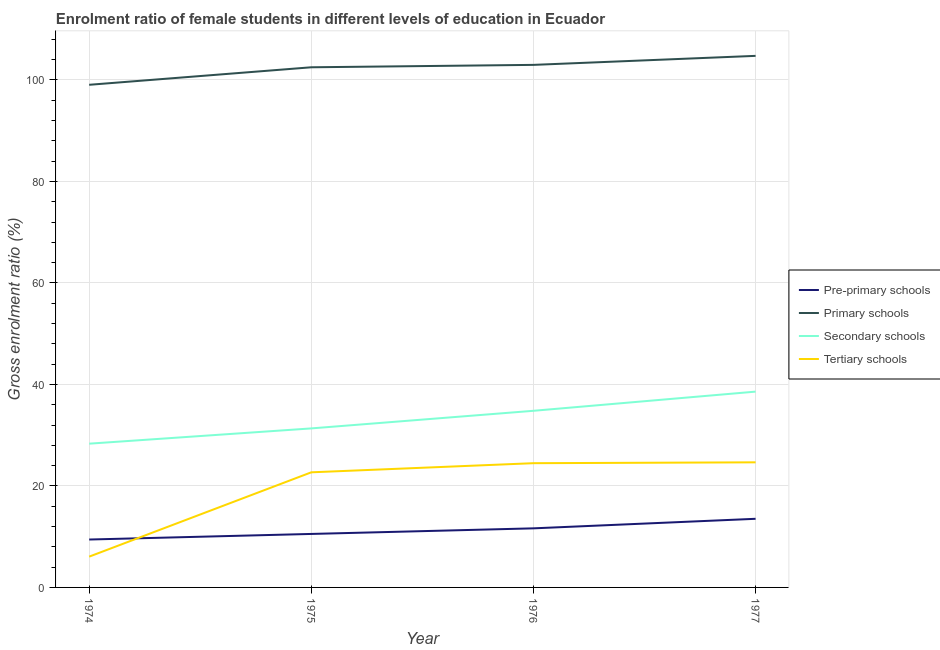Is the number of lines equal to the number of legend labels?
Provide a succinct answer. Yes. What is the gross enrolment ratio(male) in tertiary schools in 1976?
Give a very brief answer. 24.48. Across all years, what is the maximum gross enrolment ratio(male) in tertiary schools?
Your answer should be compact. 24.65. Across all years, what is the minimum gross enrolment ratio(male) in pre-primary schools?
Offer a terse response. 9.44. In which year was the gross enrolment ratio(male) in pre-primary schools minimum?
Keep it short and to the point. 1974. What is the total gross enrolment ratio(male) in primary schools in the graph?
Make the answer very short. 409.22. What is the difference between the gross enrolment ratio(male) in pre-primary schools in 1974 and that in 1976?
Offer a very short reply. -2.2. What is the difference between the gross enrolment ratio(male) in primary schools in 1977 and the gross enrolment ratio(male) in tertiary schools in 1976?
Your response must be concise. 80.26. What is the average gross enrolment ratio(male) in pre-primary schools per year?
Ensure brevity in your answer.  11.29. In the year 1975, what is the difference between the gross enrolment ratio(male) in primary schools and gross enrolment ratio(male) in tertiary schools?
Ensure brevity in your answer.  79.8. What is the ratio of the gross enrolment ratio(male) in pre-primary schools in 1975 to that in 1977?
Keep it short and to the point. 0.78. Is the gross enrolment ratio(male) in tertiary schools in 1974 less than that in 1975?
Your answer should be compact. Yes. Is the difference between the gross enrolment ratio(male) in pre-primary schools in 1974 and 1977 greater than the difference between the gross enrolment ratio(male) in secondary schools in 1974 and 1977?
Provide a succinct answer. Yes. What is the difference between the highest and the second highest gross enrolment ratio(male) in secondary schools?
Provide a succinct answer. 3.78. What is the difference between the highest and the lowest gross enrolment ratio(male) in pre-primary schools?
Your answer should be very brief. 4.08. Is the sum of the gross enrolment ratio(male) in tertiary schools in 1975 and 1976 greater than the maximum gross enrolment ratio(male) in pre-primary schools across all years?
Provide a short and direct response. Yes. Is it the case that in every year, the sum of the gross enrolment ratio(male) in pre-primary schools and gross enrolment ratio(male) in primary schools is greater than the sum of gross enrolment ratio(male) in tertiary schools and gross enrolment ratio(male) in secondary schools?
Keep it short and to the point. Yes. Is the gross enrolment ratio(male) in tertiary schools strictly less than the gross enrolment ratio(male) in primary schools over the years?
Your answer should be compact. Yes. How many lines are there?
Ensure brevity in your answer.  4. How many years are there in the graph?
Give a very brief answer. 4. Are the values on the major ticks of Y-axis written in scientific E-notation?
Offer a very short reply. No. How many legend labels are there?
Provide a short and direct response. 4. How are the legend labels stacked?
Provide a succinct answer. Vertical. What is the title of the graph?
Your answer should be compact. Enrolment ratio of female students in different levels of education in Ecuador. Does "Secondary vocational" appear as one of the legend labels in the graph?
Provide a short and direct response. No. What is the label or title of the X-axis?
Give a very brief answer. Year. What is the label or title of the Y-axis?
Your response must be concise. Gross enrolment ratio (%). What is the Gross enrolment ratio (%) of Pre-primary schools in 1974?
Your answer should be compact. 9.44. What is the Gross enrolment ratio (%) of Primary schools in 1974?
Your response must be concise. 99.04. What is the Gross enrolment ratio (%) of Secondary schools in 1974?
Offer a terse response. 28.33. What is the Gross enrolment ratio (%) of Tertiary schools in 1974?
Provide a short and direct response. 6.07. What is the Gross enrolment ratio (%) of Pre-primary schools in 1975?
Keep it short and to the point. 10.54. What is the Gross enrolment ratio (%) of Primary schools in 1975?
Offer a very short reply. 102.49. What is the Gross enrolment ratio (%) of Secondary schools in 1975?
Your answer should be very brief. 31.33. What is the Gross enrolment ratio (%) in Tertiary schools in 1975?
Provide a short and direct response. 22.68. What is the Gross enrolment ratio (%) of Pre-primary schools in 1976?
Provide a short and direct response. 11.64. What is the Gross enrolment ratio (%) of Primary schools in 1976?
Your answer should be very brief. 102.96. What is the Gross enrolment ratio (%) of Secondary schools in 1976?
Provide a short and direct response. 34.8. What is the Gross enrolment ratio (%) in Tertiary schools in 1976?
Provide a succinct answer. 24.48. What is the Gross enrolment ratio (%) in Pre-primary schools in 1977?
Offer a very short reply. 13.52. What is the Gross enrolment ratio (%) in Primary schools in 1977?
Make the answer very short. 104.74. What is the Gross enrolment ratio (%) in Secondary schools in 1977?
Keep it short and to the point. 38.58. What is the Gross enrolment ratio (%) of Tertiary schools in 1977?
Give a very brief answer. 24.65. Across all years, what is the maximum Gross enrolment ratio (%) in Pre-primary schools?
Ensure brevity in your answer.  13.52. Across all years, what is the maximum Gross enrolment ratio (%) of Primary schools?
Give a very brief answer. 104.74. Across all years, what is the maximum Gross enrolment ratio (%) in Secondary schools?
Offer a very short reply. 38.58. Across all years, what is the maximum Gross enrolment ratio (%) in Tertiary schools?
Your answer should be compact. 24.65. Across all years, what is the minimum Gross enrolment ratio (%) of Pre-primary schools?
Ensure brevity in your answer.  9.44. Across all years, what is the minimum Gross enrolment ratio (%) in Primary schools?
Your response must be concise. 99.04. Across all years, what is the minimum Gross enrolment ratio (%) in Secondary schools?
Offer a terse response. 28.33. Across all years, what is the minimum Gross enrolment ratio (%) of Tertiary schools?
Provide a succinct answer. 6.07. What is the total Gross enrolment ratio (%) of Pre-primary schools in the graph?
Offer a terse response. 45.14. What is the total Gross enrolment ratio (%) in Primary schools in the graph?
Your response must be concise. 409.22. What is the total Gross enrolment ratio (%) in Secondary schools in the graph?
Your response must be concise. 133.04. What is the total Gross enrolment ratio (%) of Tertiary schools in the graph?
Your answer should be very brief. 77.88. What is the difference between the Gross enrolment ratio (%) in Pre-primary schools in 1974 and that in 1975?
Your answer should be compact. -1.1. What is the difference between the Gross enrolment ratio (%) of Primary schools in 1974 and that in 1975?
Offer a very short reply. -3.45. What is the difference between the Gross enrolment ratio (%) of Secondary schools in 1974 and that in 1975?
Ensure brevity in your answer.  -3.01. What is the difference between the Gross enrolment ratio (%) in Tertiary schools in 1974 and that in 1975?
Give a very brief answer. -16.62. What is the difference between the Gross enrolment ratio (%) in Pre-primary schools in 1974 and that in 1976?
Give a very brief answer. -2.2. What is the difference between the Gross enrolment ratio (%) of Primary schools in 1974 and that in 1976?
Offer a very short reply. -3.92. What is the difference between the Gross enrolment ratio (%) of Secondary schools in 1974 and that in 1976?
Keep it short and to the point. -6.48. What is the difference between the Gross enrolment ratio (%) of Tertiary schools in 1974 and that in 1976?
Your answer should be compact. -18.41. What is the difference between the Gross enrolment ratio (%) of Pre-primary schools in 1974 and that in 1977?
Your response must be concise. -4.08. What is the difference between the Gross enrolment ratio (%) in Primary schools in 1974 and that in 1977?
Your answer should be very brief. -5.7. What is the difference between the Gross enrolment ratio (%) in Secondary schools in 1974 and that in 1977?
Your answer should be very brief. -10.25. What is the difference between the Gross enrolment ratio (%) in Tertiary schools in 1974 and that in 1977?
Provide a short and direct response. -18.58. What is the difference between the Gross enrolment ratio (%) of Primary schools in 1975 and that in 1976?
Your answer should be compact. -0.47. What is the difference between the Gross enrolment ratio (%) of Secondary schools in 1975 and that in 1976?
Your response must be concise. -3.47. What is the difference between the Gross enrolment ratio (%) in Tertiary schools in 1975 and that in 1976?
Provide a succinct answer. -1.8. What is the difference between the Gross enrolment ratio (%) of Pre-primary schools in 1975 and that in 1977?
Ensure brevity in your answer.  -2.98. What is the difference between the Gross enrolment ratio (%) in Primary schools in 1975 and that in 1977?
Give a very brief answer. -2.25. What is the difference between the Gross enrolment ratio (%) of Secondary schools in 1975 and that in 1977?
Provide a succinct answer. -7.25. What is the difference between the Gross enrolment ratio (%) of Tertiary schools in 1975 and that in 1977?
Provide a short and direct response. -1.97. What is the difference between the Gross enrolment ratio (%) in Pre-primary schools in 1976 and that in 1977?
Offer a terse response. -1.88. What is the difference between the Gross enrolment ratio (%) in Primary schools in 1976 and that in 1977?
Ensure brevity in your answer.  -1.78. What is the difference between the Gross enrolment ratio (%) in Secondary schools in 1976 and that in 1977?
Provide a succinct answer. -3.78. What is the difference between the Gross enrolment ratio (%) of Tertiary schools in 1976 and that in 1977?
Offer a terse response. -0.17. What is the difference between the Gross enrolment ratio (%) in Pre-primary schools in 1974 and the Gross enrolment ratio (%) in Primary schools in 1975?
Keep it short and to the point. -93.05. What is the difference between the Gross enrolment ratio (%) in Pre-primary schools in 1974 and the Gross enrolment ratio (%) in Secondary schools in 1975?
Your response must be concise. -21.89. What is the difference between the Gross enrolment ratio (%) in Pre-primary schools in 1974 and the Gross enrolment ratio (%) in Tertiary schools in 1975?
Offer a very short reply. -13.24. What is the difference between the Gross enrolment ratio (%) of Primary schools in 1974 and the Gross enrolment ratio (%) of Secondary schools in 1975?
Give a very brief answer. 67.7. What is the difference between the Gross enrolment ratio (%) of Primary schools in 1974 and the Gross enrolment ratio (%) of Tertiary schools in 1975?
Give a very brief answer. 76.35. What is the difference between the Gross enrolment ratio (%) in Secondary schools in 1974 and the Gross enrolment ratio (%) in Tertiary schools in 1975?
Provide a succinct answer. 5.64. What is the difference between the Gross enrolment ratio (%) of Pre-primary schools in 1974 and the Gross enrolment ratio (%) of Primary schools in 1976?
Your answer should be compact. -93.52. What is the difference between the Gross enrolment ratio (%) in Pre-primary schools in 1974 and the Gross enrolment ratio (%) in Secondary schools in 1976?
Ensure brevity in your answer.  -25.36. What is the difference between the Gross enrolment ratio (%) of Pre-primary schools in 1974 and the Gross enrolment ratio (%) of Tertiary schools in 1976?
Provide a succinct answer. -15.04. What is the difference between the Gross enrolment ratio (%) in Primary schools in 1974 and the Gross enrolment ratio (%) in Secondary schools in 1976?
Give a very brief answer. 64.23. What is the difference between the Gross enrolment ratio (%) of Primary schools in 1974 and the Gross enrolment ratio (%) of Tertiary schools in 1976?
Your response must be concise. 74.56. What is the difference between the Gross enrolment ratio (%) of Secondary schools in 1974 and the Gross enrolment ratio (%) of Tertiary schools in 1976?
Offer a terse response. 3.85. What is the difference between the Gross enrolment ratio (%) in Pre-primary schools in 1974 and the Gross enrolment ratio (%) in Primary schools in 1977?
Ensure brevity in your answer.  -95.3. What is the difference between the Gross enrolment ratio (%) of Pre-primary schools in 1974 and the Gross enrolment ratio (%) of Secondary schools in 1977?
Your response must be concise. -29.14. What is the difference between the Gross enrolment ratio (%) of Pre-primary schools in 1974 and the Gross enrolment ratio (%) of Tertiary schools in 1977?
Your response must be concise. -15.21. What is the difference between the Gross enrolment ratio (%) of Primary schools in 1974 and the Gross enrolment ratio (%) of Secondary schools in 1977?
Your answer should be compact. 60.46. What is the difference between the Gross enrolment ratio (%) of Primary schools in 1974 and the Gross enrolment ratio (%) of Tertiary schools in 1977?
Keep it short and to the point. 74.39. What is the difference between the Gross enrolment ratio (%) of Secondary schools in 1974 and the Gross enrolment ratio (%) of Tertiary schools in 1977?
Give a very brief answer. 3.68. What is the difference between the Gross enrolment ratio (%) in Pre-primary schools in 1975 and the Gross enrolment ratio (%) in Primary schools in 1976?
Provide a short and direct response. -92.42. What is the difference between the Gross enrolment ratio (%) in Pre-primary schools in 1975 and the Gross enrolment ratio (%) in Secondary schools in 1976?
Your answer should be very brief. -24.26. What is the difference between the Gross enrolment ratio (%) in Pre-primary schools in 1975 and the Gross enrolment ratio (%) in Tertiary schools in 1976?
Give a very brief answer. -13.94. What is the difference between the Gross enrolment ratio (%) in Primary schools in 1975 and the Gross enrolment ratio (%) in Secondary schools in 1976?
Your answer should be very brief. 67.68. What is the difference between the Gross enrolment ratio (%) in Primary schools in 1975 and the Gross enrolment ratio (%) in Tertiary schools in 1976?
Your answer should be compact. 78.01. What is the difference between the Gross enrolment ratio (%) in Secondary schools in 1975 and the Gross enrolment ratio (%) in Tertiary schools in 1976?
Your response must be concise. 6.85. What is the difference between the Gross enrolment ratio (%) in Pre-primary schools in 1975 and the Gross enrolment ratio (%) in Primary schools in 1977?
Your answer should be compact. -94.2. What is the difference between the Gross enrolment ratio (%) of Pre-primary schools in 1975 and the Gross enrolment ratio (%) of Secondary schools in 1977?
Ensure brevity in your answer.  -28.04. What is the difference between the Gross enrolment ratio (%) of Pre-primary schools in 1975 and the Gross enrolment ratio (%) of Tertiary schools in 1977?
Offer a very short reply. -14.11. What is the difference between the Gross enrolment ratio (%) of Primary schools in 1975 and the Gross enrolment ratio (%) of Secondary schools in 1977?
Make the answer very short. 63.91. What is the difference between the Gross enrolment ratio (%) of Primary schools in 1975 and the Gross enrolment ratio (%) of Tertiary schools in 1977?
Provide a succinct answer. 77.84. What is the difference between the Gross enrolment ratio (%) in Secondary schools in 1975 and the Gross enrolment ratio (%) in Tertiary schools in 1977?
Ensure brevity in your answer.  6.68. What is the difference between the Gross enrolment ratio (%) of Pre-primary schools in 1976 and the Gross enrolment ratio (%) of Primary schools in 1977?
Offer a terse response. -93.1. What is the difference between the Gross enrolment ratio (%) of Pre-primary schools in 1976 and the Gross enrolment ratio (%) of Secondary schools in 1977?
Give a very brief answer. -26.94. What is the difference between the Gross enrolment ratio (%) of Pre-primary schools in 1976 and the Gross enrolment ratio (%) of Tertiary schools in 1977?
Offer a very short reply. -13.01. What is the difference between the Gross enrolment ratio (%) of Primary schools in 1976 and the Gross enrolment ratio (%) of Secondary schools in 1977?
Offer a very short reply. 64.38. What is the difference between the Gross enrolment ratio (%) of Primary schools in 1976 and the Gross enrolment ratio (%) of Tertiary schools in 1977?
Your answer should be compact. 78.31. What is the difference between the Gross enrolment ratio (%) of Secondary schools in 1976 and the Gross enrolment ratio (%) of Tertiary schools in 1977?
Keep it short and to the point. 10.15. What is the average Gross enrolment ratio (%) of Pre-primary schools per year?
Give a very brief answer. 11.29. What is the average Gross enrolment ratio (%) of Primary schools per year?
Offer a very short reply. 102.3. What is the average Gross enrolment ratio (%) in Secondary schools per year?
Ensure brevity in your answer.  33.26. What is the average Gross enrolment ratio (%) in Tertiary schools per year?
Give a very brief answer. 19.47. In the year 1974, what is the difference between the Gross enrolment ratio (%) in Pre-primary schools and Gross enrolment ratio (%) in Primary schools?
Keep it short and to the point. -89.6. In the year 1974, what is the difference between the Gross enrolment ratio (%) in Pre-primary schools and Gross enrolment ratio (%) in Secondary schools?
Offer a very short reply. -18.89. In the year 1974, what is the difference between the Gross enrolment ratio (%) in Pre-primary schools and Gross enrolment ratio (%) in Tertiary schools?
Your response must be concise. 3.37. In the year 1974, what is the difference between the Gross enrolment ratio (%) in Primary schools and Gross enrolment ratio (%) in Secondary schools?
Provide a short and direct response. 70.71. In the year 1974, what is the difference between the Gross enrolment ratio (%) in Primary schools and Gross enrolment ratio (%) in Tertiary schools?
Provide a short and direct response. 92.97. In the year 1974, what is the difference between the Gross enrolment ratio (%) of Secondary schools and Gross enrolment ratio (%) of Tertiary schools?
Provide a short and direct response. 22.26. In the year 1975, what is the difference between the Gross enrolment ratio (%) of Pre-primary schools and Gross enrolment ratio (%) of Primary schools?
Make the answer very short. -91.95. In the year 1975, what is the difference between the Gross enrolment ratio (%) in Pre-primary schools and Gross enrolment ratio (%) in Secondary schools?
Keep it short and to the point. -20.79. In the year 1975, what is the difference between the Gross enrolment ratio (%) of Pre-primary schools and Gross enrolment ratio (%) of Tertiary schools?
Make the answer very short. -12.14. In the year 1975, what is the difference between the Gross enrolment ratio (%) in Primary schools and Gross enrolment ratio (%) in Secondary schools?
Offer a very short reply. 71.15. In the year 1975, what is the difference between the Gross enrolment ratio (%) in Primary schools and Gross enrolment ratio (%) in Tertiary schools?
Keep it short and to the point. 79.8. In the year 1975, what is the difference between the Gross enrolment ratio (%) in Secondary schools and Gross enrolment ratio (%) in Tertiary schools?
Provide a short and direct response. 8.65. In the year 1976, what is the difference between the Gross enrolment ratio (%) of Pre-primary schools and Gross enrolment ratio (%) of Primary schools?
Your answer should be very brief. -91.32. In the year 1976, what is the difference between the Gross enrolment ratio (%) of Pre-primary schools and Gross enrolment ratio (%) of Secondary schools?
Provide a succinct answer. -23.16. In the year 1976, what is the difference between the Gross enrolment ratio (%) in Pre-primary schools and Gross enrolment ratio (%) in Tertiary schools?
Offer a terse response. -12.84. In the year 1976, what is the difference between the Gross enrolment ratio (%) in Primary schools and Gross enrolment ratio (%) in Secondary schools?
Offer a very short reply. 68.16. In the year 1976, what is the difference between the Gross enrolment ratio (%) in Primary schools and Gross enrolment ratio (%) in Tertiary schools?
Make the answer very short. 78.48. In the year 1976, what is the difference between the Gross enrolment ratio (%) of Secondary schools and Gross enrolment ratio (%) of Tertiary schools?
Ensure brevity in your answer.  10.32. In the year 1977, what is the difference between the Gross enrolment ratio (%) of Pre-primary schools and Gross enrolment ratio (%) of Primary schools?
Provide a succinct answer. -91.21. In the year 1977, what is the difference between the Gross enrolment ratio (%) of Pre-primary schools and Gross enrolment ratio (%) of Secondary schools?
Provide a short and direct response. -25.06. In the year 1977, what is the difference between the Gross enrolment ratio (%) of Pre-primary schools and Gross enrolment ratio (%) of Tertiary schools?
Make the answer very short. -11.13. In the year 1977, what is the difference between the Gross enrolment ratio (%) of Primary schools and Gross enrolment ratio (%) of Secondary schools?
Offer a very short reply. 66.16. In the year 1977, what is the difference between the Gross enrolment ratio (%) in Primary schools and Gross enrolment ratio (%) in Tertiary schools?
Make the answer very short. 80.09. In the year 1977, what is the difference between the Gross enrolment ratio (%) in Secondary schools and Gross enrolment ratio (%) in Tertiary schools?
Provide a short and direct response. 13.93. What is the ratio of the Gross enrolment ratio (%) of Pre-primary schools in 1974 to that in 1975?
Offer a very short reply. 0.9. What is the ratio of the Gross enrolment ratio (%) of Primary schools in 1974 to that in 1975?
Provide a short and direct response. 0.97. What is the ratio of the Gross enrolment ratio (%) of Secondary schools in 1974 to that in 1975?
Offer a terse response. 0.9. What is the ratio of the Gross enrolment ratio (%) in Tertiary schools in 1974 to that in 1975?
Your answer should be compact. 0.27. What is the ratio of the Gross enrolment ratio (%) of Pre-primary schools in 1974 to that in 1976?
Offer a very short reply. 0.81. What is the ratio of the Gross enrolment ratio (%) of Primary schools in 1974 to that in 1976?
Your answer should be very brief. 0.96. What is the ratio of the Gross enrolment ratio (%) of Secondary schools in 1974 to that in 1976?
Provide a short and direct response. 0.81. What is the ratio of the Gross enrolment ratio (%) in Tertiary schools in 1974 to that in 1976?
Give a very brief answer. 0.25. What is the ratio of the Gross enrolment ratio (%) of Pre-primary schools in 1974 to that in 1977?
Keep it short and to the point. 0.7. What is the ratio of the Gross enrolment ratio (%) in Primary schools in 1974 to that in 1977?
Offer a terse response. 0.95. What is the ratio of the Gross enrolment ratio (%) of Secondary schools in 1974 to that in 1977?
Keep it short and to the point. 0.73. What is the ratio of the Gross enrolment ratio (%) of Tertiary schools in 1974 to that in 1977?
Your response must be concise. 0.25. What is the ratio of the Gross enrolment ratio (%) of Pre-primary schools in 1975 to that in 1976?
Your response must be concise. 0.91. What is the ratio of the Gross enrolment ratio (%) in Primary schools in 1975 to that in 1976?
Provide a succinct answer. 1. What is the ratio of the Gross enrolment ratio (%) of Secondary schools in 1975 to that in 1976?
Ensure brevity in your answer.  0.9. What is the ratio of the Gross enrolment ratio (%) of Tertiary schools in 1975 to that in 1976?
Offer a very short reply. 0.93. What is the ratio of the Gross enrolment ratio (%) of Pre-primary schools in 1975 to that in 1977?
Offer a very short reply. 0.78. What is the ratio of the Gross enrolment ratio (%) of Primary schools in 1975 to that in 1977?
Make the answer very short. 0.98. What is the ratio of the Gross enrolment ratio (%) of Secondary schools in 1975 to that in 1977?
Make the answer very short. 0.81. What is the ratio of the Gross enrolment ratio (%) of Tertiary schools in 1975 to that in 1977?
Ensure brevity in your answer.  0.92. What is the ratio of the Gross enrolment ratio (%) of Pre-primary schools in 1976 to that in 1977?
Keep it short and to the point. 0.86. What is the ratio of the Gross enrolment ratio (%) of Primary schools in 1976 to that in 1977?
Offer a very short reply. 0.98. What is the ratio of the Gross enrolment ratio (%) in Secondary schools in 1976 to that in 1977?
Your answer should be compact. 0.9. What is the difference between the highest and the second highest Gross enrolment ratio (%) of Pre-primary schools?
Provide a succinct answer. 1.88. What is the difference between the highest and the second highest Gross enrolment ratio (%) in Primary schools?
Your answer should be very brief. 1.78. What is the difference between the highest and the second highest Gross enrolment ratio (%) of Secondary schools?
Provide a short and direct response. 3.78. What is the difference between the highest and the second highest Gross enrolment ratio (%) of Tertiary schools?
Provide a succinct answer. 0.17. What is the difference between the highest and the lowest Gross enrolment ratio (%) of Pre-primary schools?
Make the answer very short. 4.08. What is the difference between the highest and the lowest Gross enrolment ratio (%) of Primary schools?
Give a very brief answer. 5.7. What is the difference between the highest and the lowest Gross enrolment ratio (%) of Secondary schools?
Give a very brief answer. 10.25. What is the difference between the highest and the lowest Gross enrolment ratio (%) in Tertiary schools?
Provide a succinct answer. 18.58. 